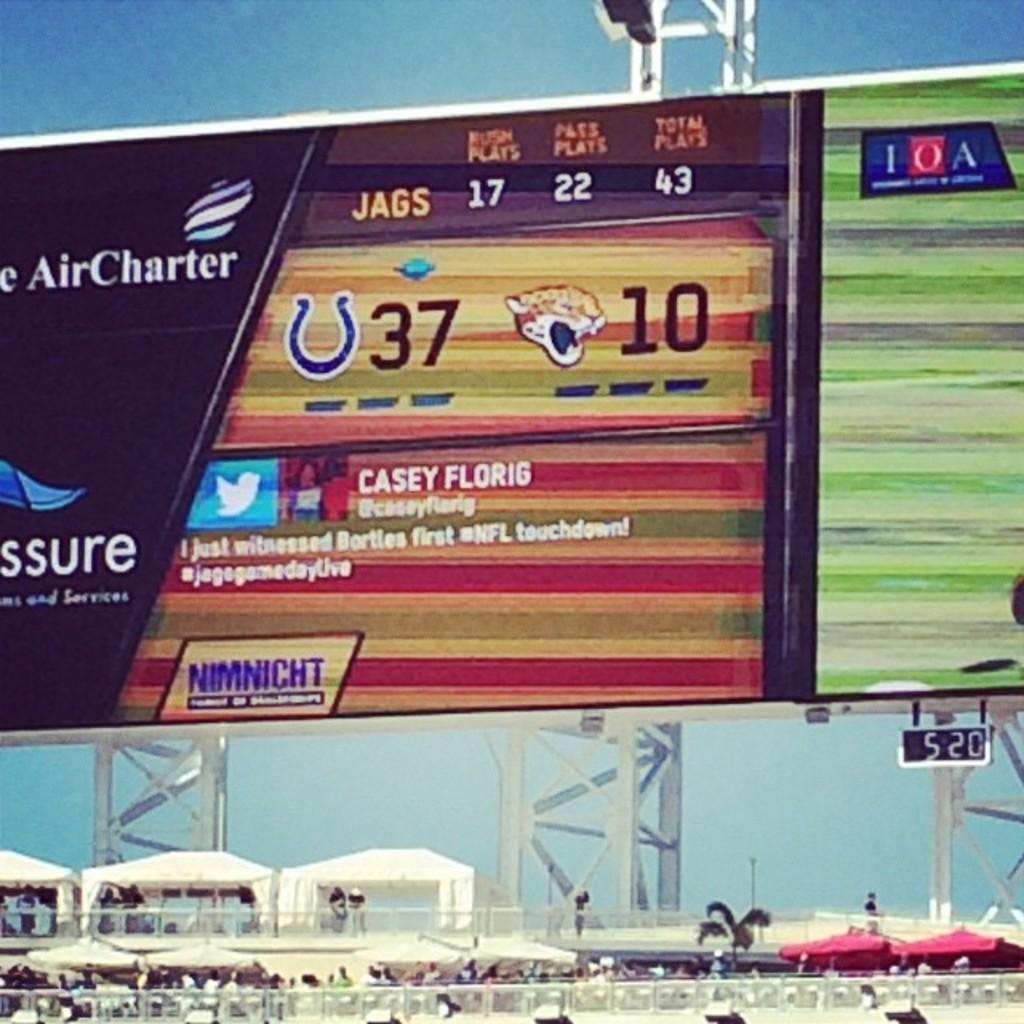<image>
Summarize the visual content of the image. A jumbotron featuring a tweet by Casey Florig during a game. 